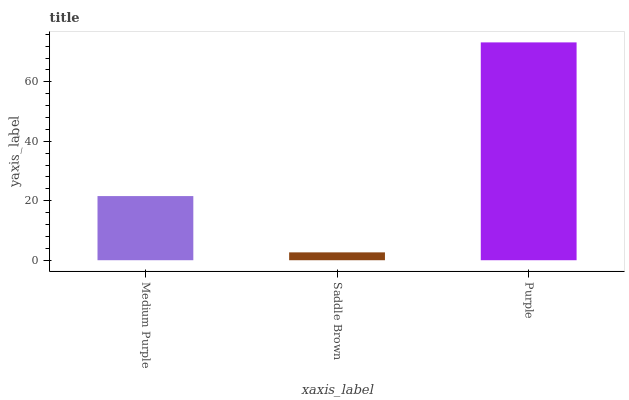Is Saddle Brown the minimum?
Answer yes or no. Yes. Is Purple the maximum?
Answer yes or no. Yes. Is Purple the minimum?
Answer yes or no. No. Is Saddle Brown the maximum?
Answer yes or no. No. Is Purple greater than Saddle Brown?
Answer yes or no. Yes. Is Saddle Brown less than Purple?
Answer yes or no. Yes. Is Saddle Brown greater than Purple?
Answer yes or no. No. Is Purple less than Saddle Brown?
Answer yes or no. No. Is Medium Purple the high median?
Answer yes or no. Yes. Is Medium Purple the low median?
Answer yes or no. Yes. Is Purple the high median?
Answer yes or no. No. Is Saddle Brown the low median?
Answer yes or no. No. 